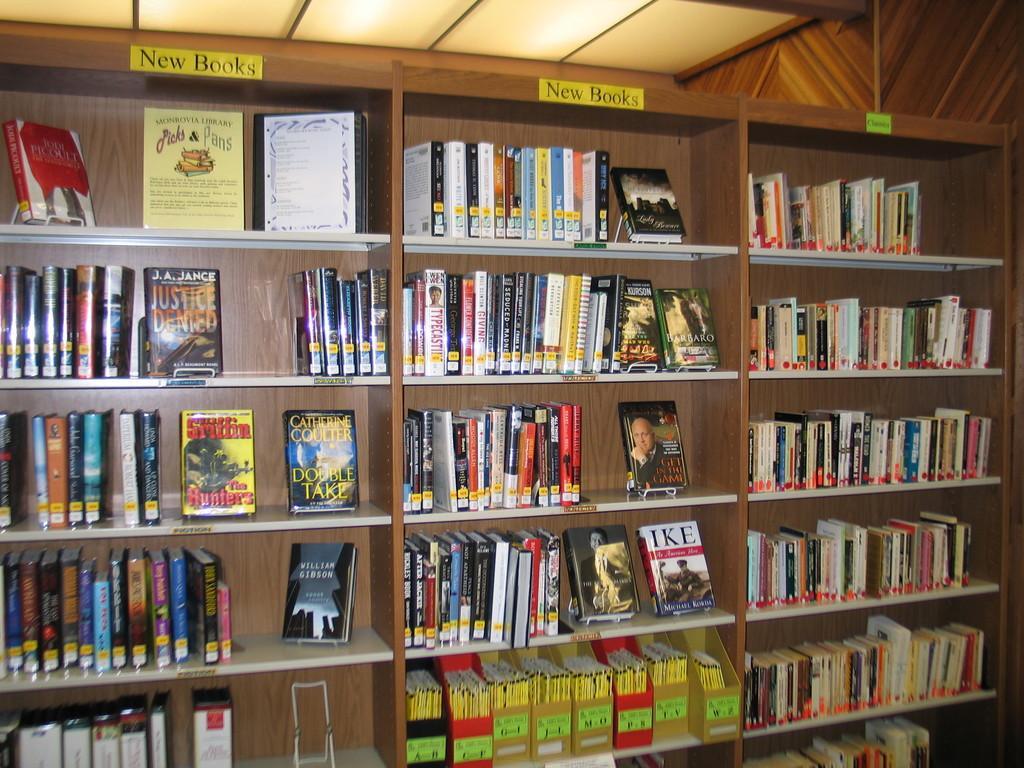Could you give a brief overview of what you see in this image? In this image, we can see books in the shelves and there are some stickers. At the top, there is a roof and there are lights. 